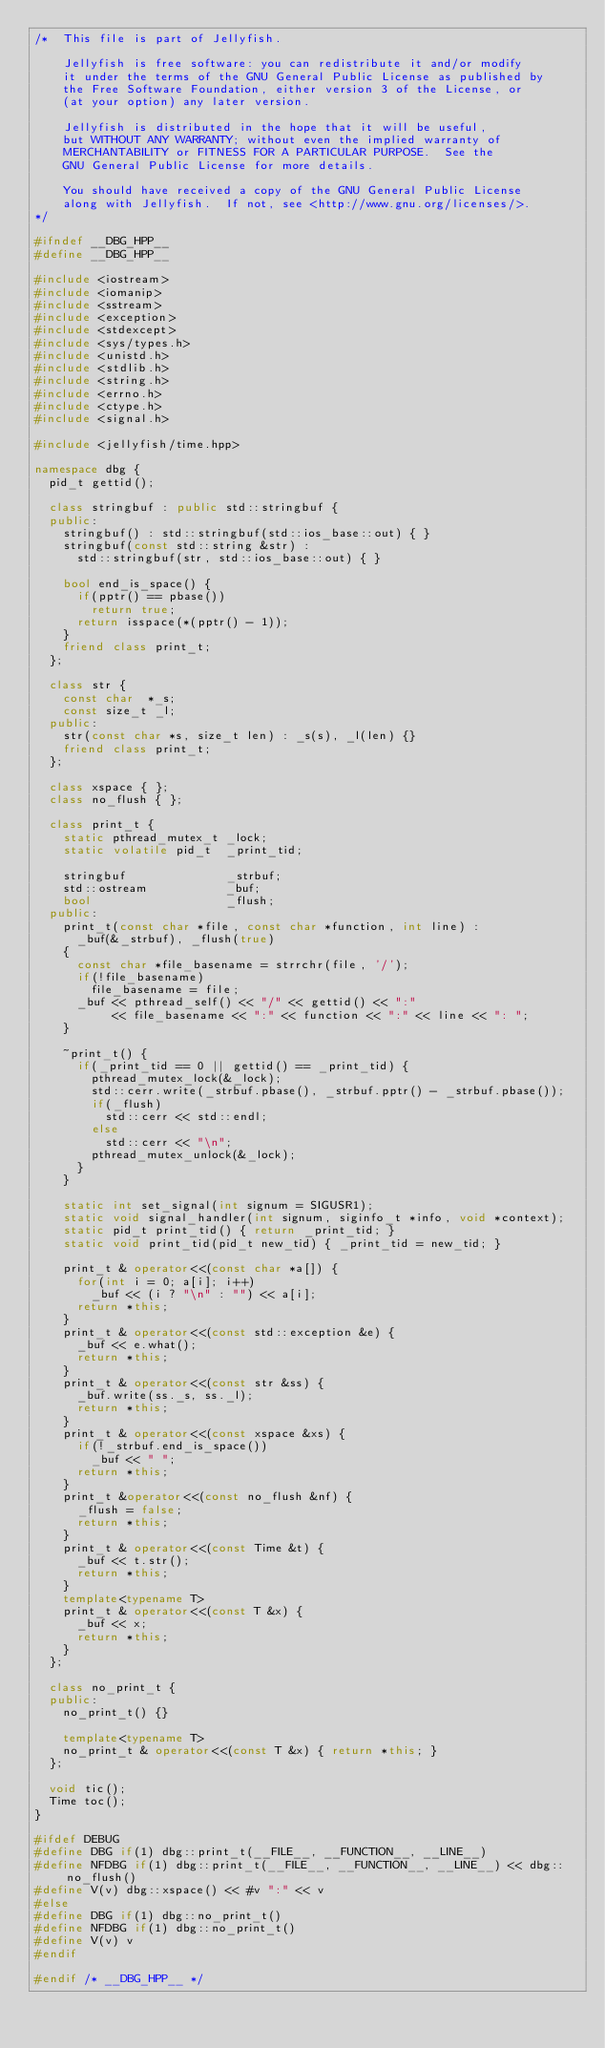<code> <loc_0><loc_0><loc_500><loc_500><_C++_>/*  This file is part of Jellyfish.

    Jellyfish is free software: you can redistribute it and/or modify
    it under the terms of the GNU General Public License as published by
    the Free Software Foundation, either version 3 of the License, or
    (at your option) any later version.

    Jellyfish is distributed in the hope that it will be useful,
    but WITHOUT ANY WARRANTY; without even the implied warranty of
    MERCHANTABILITY or FITNESS FOR A PARTICULAR PURPOSE.  See the
    GNU General Public License for more details.

    You should have received a copy of the GNU General Public License
    along with Jellyfish.  If not, see <http://www.gnu.org/licenses/>.
*/

#ifndef __DBG_HPP__
#define __DBG_HPP__

#include <iostream>
#include <iomanip>
#include <sstream>
#include <exception>
#include <stdexcept>
#include <sys/types.h>
#include <unistd.h>
#include <stdlib.h>
#include <string.h>
#include <errno.h>
#include <ctype.h>
#include <signal.h>

#include <jellyfish/time.hpp>

namespace dbg {
  pid_t gettid();

  class stringbuf : public std::stringbuf {
  public:
    stringbuf() : std::stringbuf(std::ios_base::out) { }
    stringbuf(const std::string &str) : 
      std::stringbuf(str, std::ios_base::out) { }

    bool end_is_space() {
      if(pptr() == pbase())
        return true;
      return isspace(*(pptr() - 1));
    }
    friend class print_t;
  };

  class str {
    const char  *_s;
    const size_t _l;
  public:
    str(const char *s, size_t len) : _s(s), _l(len) {}
    friend class print_t;
  };

  class xspace { };
  class no_flush { };

  class print_t {
    static pthread_mutex_t _lock;
    static volatile pid_t  _print_tid;

    stringbuf              _strbuf;
    std::ostream           _buf;
    bool                   _flush;
  public:
    print_t(const char *file, const char *function, int line) :
      _buf(&_strbuf), _flush(true)
    {
      const char *file_basename = strrchr(file, '/');
      if(!file_basename)
        file_basename = file;
      _buf << pthread_self() << "/" << gettid() << ":"
           << file_basename << ":" << function << ":" << line << ": ";
    }

    ~print_t() {
      if(_print_tid == 0 || gettid() == _print_tid) {
        pthread_mutex_lock(&_lock);
        std::cerr.write(_strbuf.pbase(), _strbuf.pptr() - _strbuf.pbase());
        if(_flush)
          std::cerr << std::endl;
        else
          std::cerr << "\n";
        pthread_mutex_unlock(&_lock);
      }
    }

    static int set_signal(int signum = SIGUSR1);
    static void signal_handler(int signum, siginfo_t *info, void *context);
    static pid_t print_tid() { return _print_tid; }
    static void print_tid(pid_t new_tid) { _print_tid = new_tid; }

    print_t & operator<<(const char *a[]) {
      for(int i = 0; a[i]; i++)
        _buf << (i ? "\n" : "") << a[i];
      return *this;
    }
    print_t & operator<<(const std::exception &e) {
      _buf << e.what();
      return *this;
    }
    print_t & operator<<(const str &ss) {
      _buf.write(ss._s, ss._l);
      return *this;
    }
    print_t & operator<<(const xspace &xs) {
      if(!_strbuf.end_is_space())
        _buf << " ";
      return *this;
    }
    print_t &operator<<(const no_flush &nf) {
      _flush = false;
      return *this;
    }
    print_t & operator<<(const Time &t) {
      _buf << t.str();
      return *this;
    }
    template<typename T>
    print_t & operator<<(const T &x) {
      _buf << x;
      return *this;
    }
  };

  class no_print_t {
  public:
    no_print_t() {}
    
    template<typename T>
    no_print_t & operator<<(const T &x) { return *this; }
  };

  void tic();
  Time toc();
}

#ifdef DEBUG
#define DBG if(1) dbg::print_t(__FILE__, __FUNCTION__, __LINE__)
#define NFDBG if(1) dbg::print_t(__FILE__, __FUNCTION__, __LINE__) << dbg::no_flush()
#define V(v) dbg::xspace() << #v ":" << v
#else
#define DBG if(1) dbg::no_print_t()
#define NFDBG if(1) dbg::no_print_t()
#define V(v) v
#endif

#endif /* __DBG_HPP__ */
</code> 